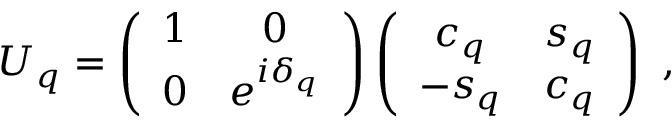Convert formula to latex. <formula><loc_0><loc_0><loc_500><loc_500>U _ { q } = \left ( \begin{array} { c c } { 1 } & { 0 } \\ { 0 } & { { e ^ { i \delta _ { q } } } } \end{array} \right ) \left ( \begin{array} { c c } { { c _ { q } } } & { { s _ { q } } } \\ { { - s _ { q } } } & { { c _ { q } } } \end{array} \right ) \ ,</formula> 